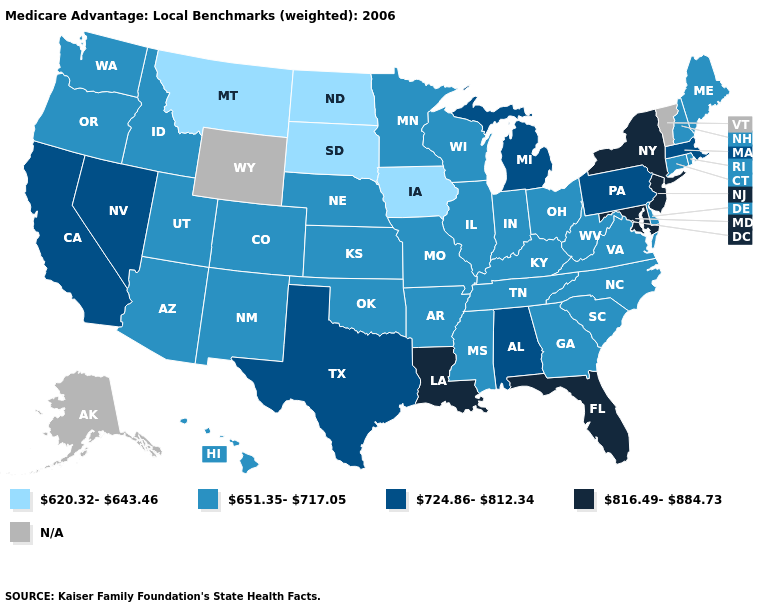Name the states that have a value in the range 651.35-717.05?
Give a very brief answer. Arkansas, Arizona, Colorado, Connecticut, Delaware, Georgia, Hawaii, Idaho, Illinois, Indiana, Kansas, Kentucky, Maine, Minnesota, Missouri, Mississippi, North Carolina, Nebraska, New Hampshire, New Mexico, Ohio, Oklahoma, Oregon, Rhode Island, South Carolina, Tennessee, Utah, Virginia, Washington, Wisconsin, West Virginia. What is the value of Mississippi?
Answer briefly. 651.35-717.05. What is the highest value in states that border Nevada?
Quick response, please. 724.86-812.34. Does the map have missing data?
Write a very short answer. Yes. Among the states that border Arkansas , does Louisiana have the lowest value?
Concise answer only. No. Which states have the highest value in the USA?
Write a very short answer. Florida, Louisiana, Maryland, New Jersey, New York. Name the states that have a value in the range 724.86-812.34?
Answer briefly. Alabama, California, Massachusetts, Michigan, Nevada, Pennsylvania, Texas. Name the states that have a value in the range 620.32-643.46?
Answer briefly. Iowa, Montana, North Dakota, South Dakota. What is the value of Maryland?
Answer briefly. 816.49-884.73. What is the value of Minnesota?
Give a very brief answer. 651.35-717.05. Name the states that have a value in the range 816.49-884.73?
Keep it brief. Florida, Louisiana, Maryland, New Jersey, New York. What is the highest value in the South ?
Be succinct. 816.49-884.73. Which states have the lowest value in the South?
Quick response, please. Arkansas, Delaware, Georgia, Kentucky, Mississippi, North Carolina, Oklahoma, South Carolina, Tennessee, Virginia, West Virginia. Does Arizona have the highest value in the USA?
Quick response, please. No. 